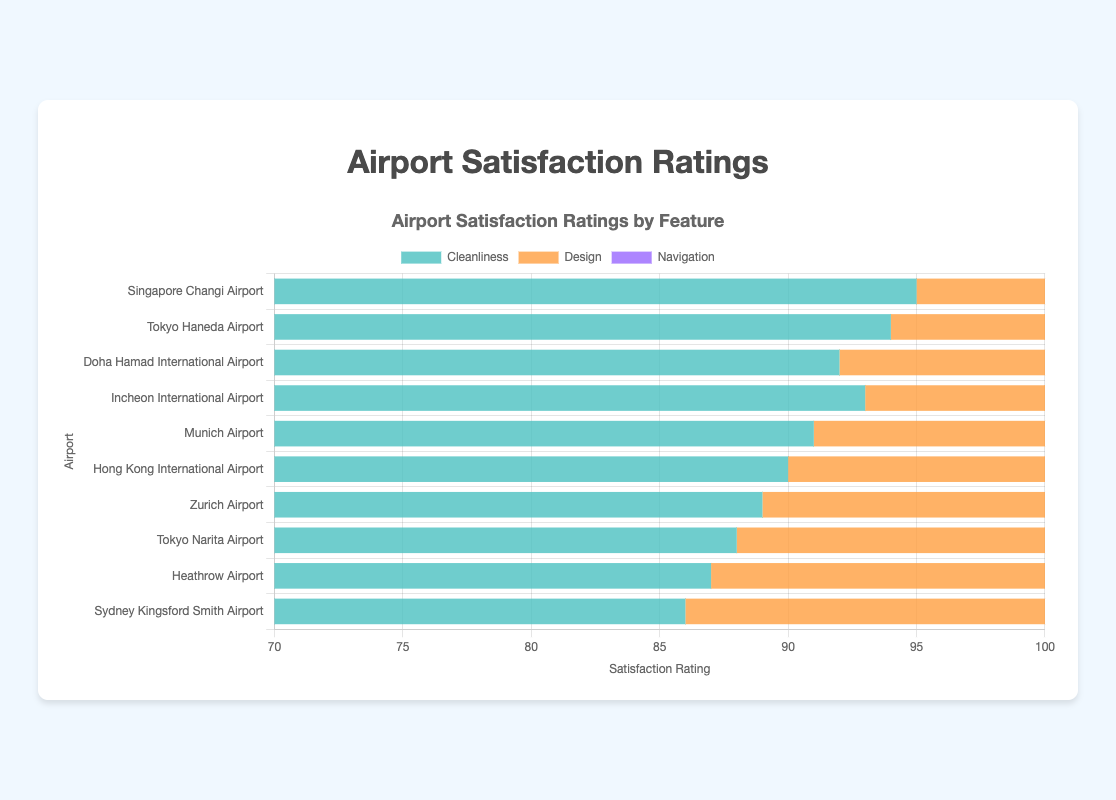Which airport has the highest satisfaction rating for cleanliness? Singapore Changi Airport has the highest cleanliness rating of 95, shown by the length of the green bar being the longest among the cleanliness bars.
Answer: Singapore Changi Airport Which airport has a higher rating for design, Doha Hamad International Airport or Incheon International Airport? Doha Hamad International Airport has a design rating of 93, while Incheon International Airport has a rating of 91. Observed by comparing the lengths of the orange bars for both airports.
Answer: Doha Hamad International Airport What is the average navigation rating of Tokyo Haneda Airport and Zurich Airport? The navigation ratings for Tokyo Haneda Airport and Zurich Airport are 87 and 83, respectively. Calculate (87 + 83) / 2 to get the average navigation rating.
Answer: 85 Which airport has the lowest satisfaction rating for navigation? Sydney Kingsford Smith Airport has the lowest navigation rating of 79, as indicated by the shortest purple bar in the navigation category.
Answer: Sydney Kingsford Smith Airport What is the combined cleanliness rating of Munich Airport and Zurich Airport? Munich Airport has a cleanliness rating of 91, and Zurich Airport has a rating of 89. The sum of these ratings is 91 + 89.
Answer: 180 Which airport has the smallest difference in ratings between design and navigation? Calculate the differences between design and navigation ratings for each airport. The smallest difference is for Doha Hamad International Airport with a difference of 93 - 88 = 5.
Answer: Doha Hamad International Airport What is the range of the satisfaction ratings for the design feature across all airports? The highest design rating is 93 (Doha Hamad International Airport), and the lowest is 83 (Sydney Kingsford Smith Airport). The range is 93 - 83.
Answer: 10 Which airport has a higher total satisfaction rating sum (cleanliness + design + navigation), Tokyo Narita Airport or Heathrow Airport? The total rating sum for Tokyo Narita Airport is 88 + 85 + 82 = 255. For Heathrow Airport, it is 87 + 84 + 80 = 251, making Tokyo Narita Airport higher.
Answer: Tokyo Narita Airport What’s the difference between the highest and lowest cleanliness ratings? The highest cleanliness rating is 95 (Singapore Changi Airport), and the lowest is 86 (Sydney Kingsford Smith Airport). The difference is 95 - 86.
Answer: 9 Which airport has a higher overall average satisfaction rating (cleanliness + design + navigation) per feature, Incheon International Airport or Hong Kong International Airport? Calculate the overall average satisfaction rating for each airport. Incheon International Airport has (93 + 91 + 86) / 3 = 90, and Hong Kong International Airport has (90 + 88 + 84) / 3 = 87.
Answer: Incheon International Airport 